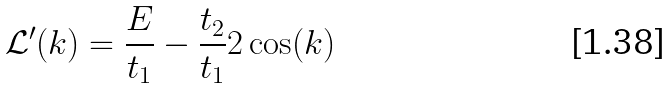<formula> <loc_0><loc_0><loc_500><loc_500>\mathcal { L } ^ { \prime } ( k ) = \frac { E } { t _ { 1 } } - \frac { t _ { 2 } } { t _ { 1 } } 2 \cos ( k )</formula> 